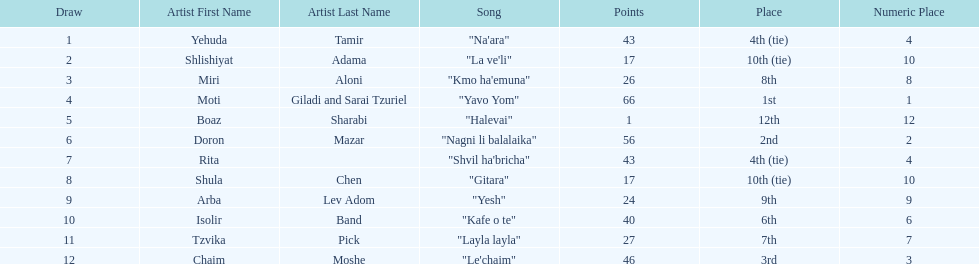What song is listed in the table right before layla layla? "Kafe o te". 